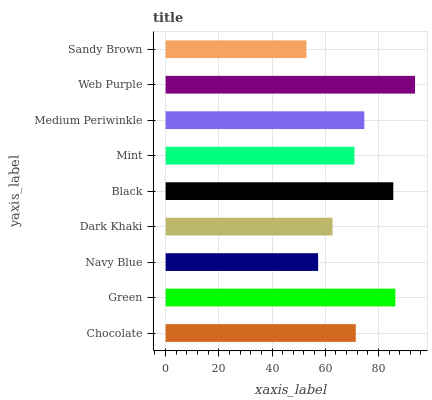Is Sandy Brown the minimum?
Answer yes or no. Yes. Is Web Purple the maximum?
Answer yes or no. Yes. Is Green the minimum?
Answer yes or no. No. Is Green the maximum?
Answer yes or no. No. Is Green greater than Chocolate?
Answer yes or no. Yes. Is Chocolate less than Green?
Answer yes or no. Yes. Is Chocolate greater than Green?
Answer yes or no. No. Is Green less than Chocolate?
Answer yes or no. No. Is Chocolate the high median?
Answer yes or no. Yes. Is Chocolate the low median?
Answer yes or no. Yes. Is Dark Khaki the high median?
Answer yes or no. No. Is Black the low median?
Answer yes or no. No. 